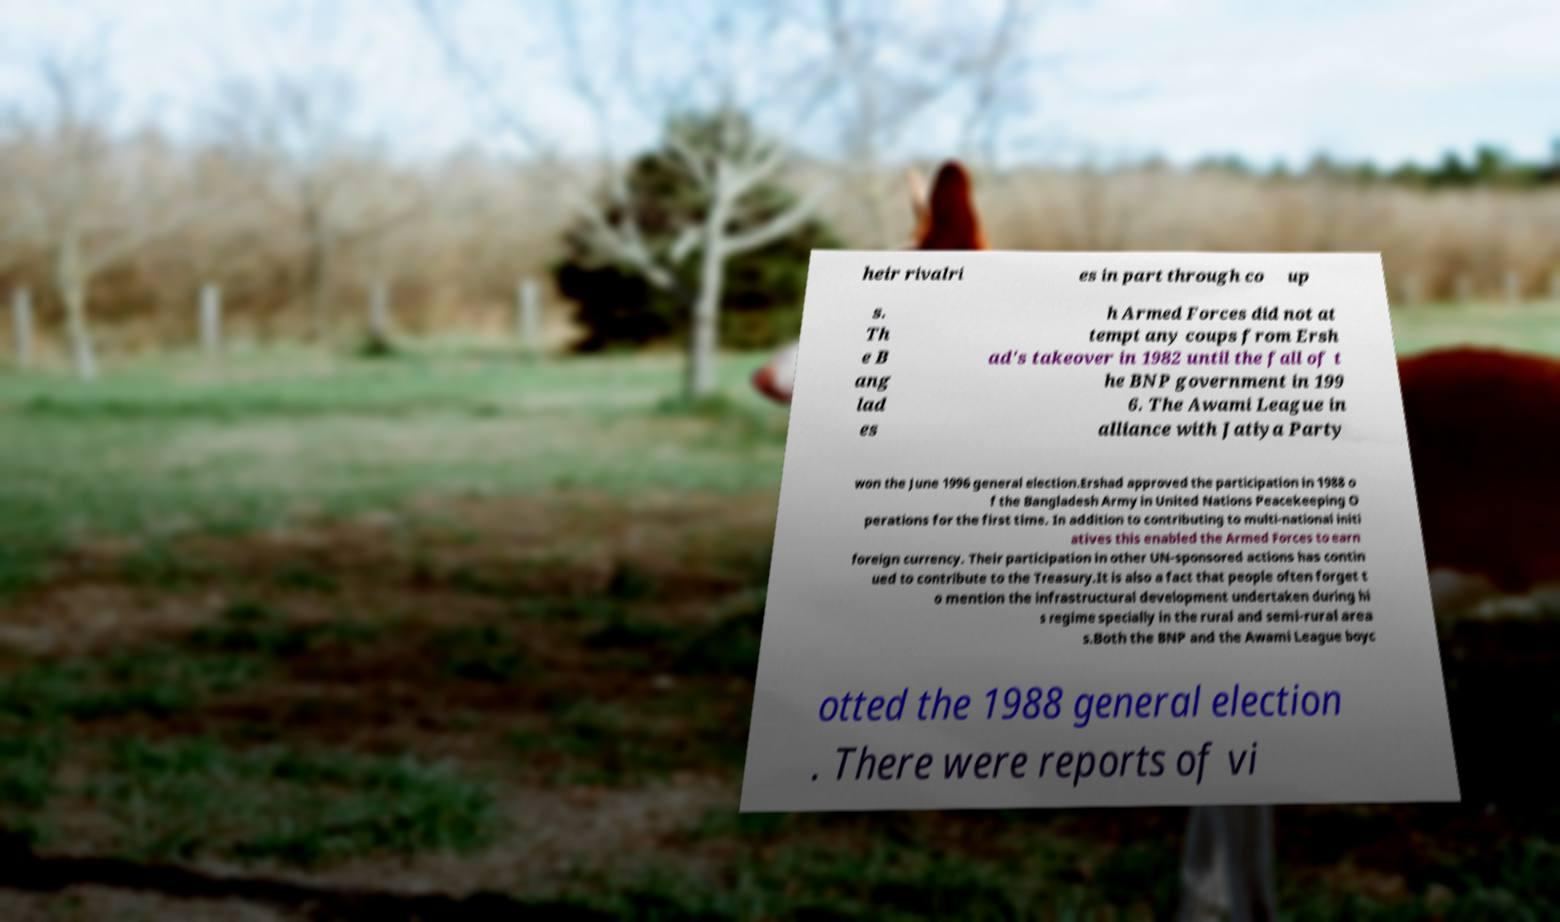Could you extract and type out the text from this image? heir rivalri es in part through co up s. Th e B ang lad es h Armed Forces did not at tempt any coups from Ersh ad's takeover in 1982 until the fall of t he BNP government in 199 6. The Awami League in alliance with Jatiya Party won the June 1996 general election.Ershad approved the participation in 1988 o f the Bangladesh Army in United Nations Peacekeeping O perations for the first time. In addition to contributing to multi-national initi atives this enabled the Armed Forces to earn foreign currency. Their participation in other UN-sponsored actions has contin ued to contribute to the Treasury.It is also a fact that people often forget t o mention the infrastructural development undertaken during hi s regime specially in the rural and semi-rural area s.Both the BNP and the Awami League boyc otted the 1988 general election . There were reports of vi 